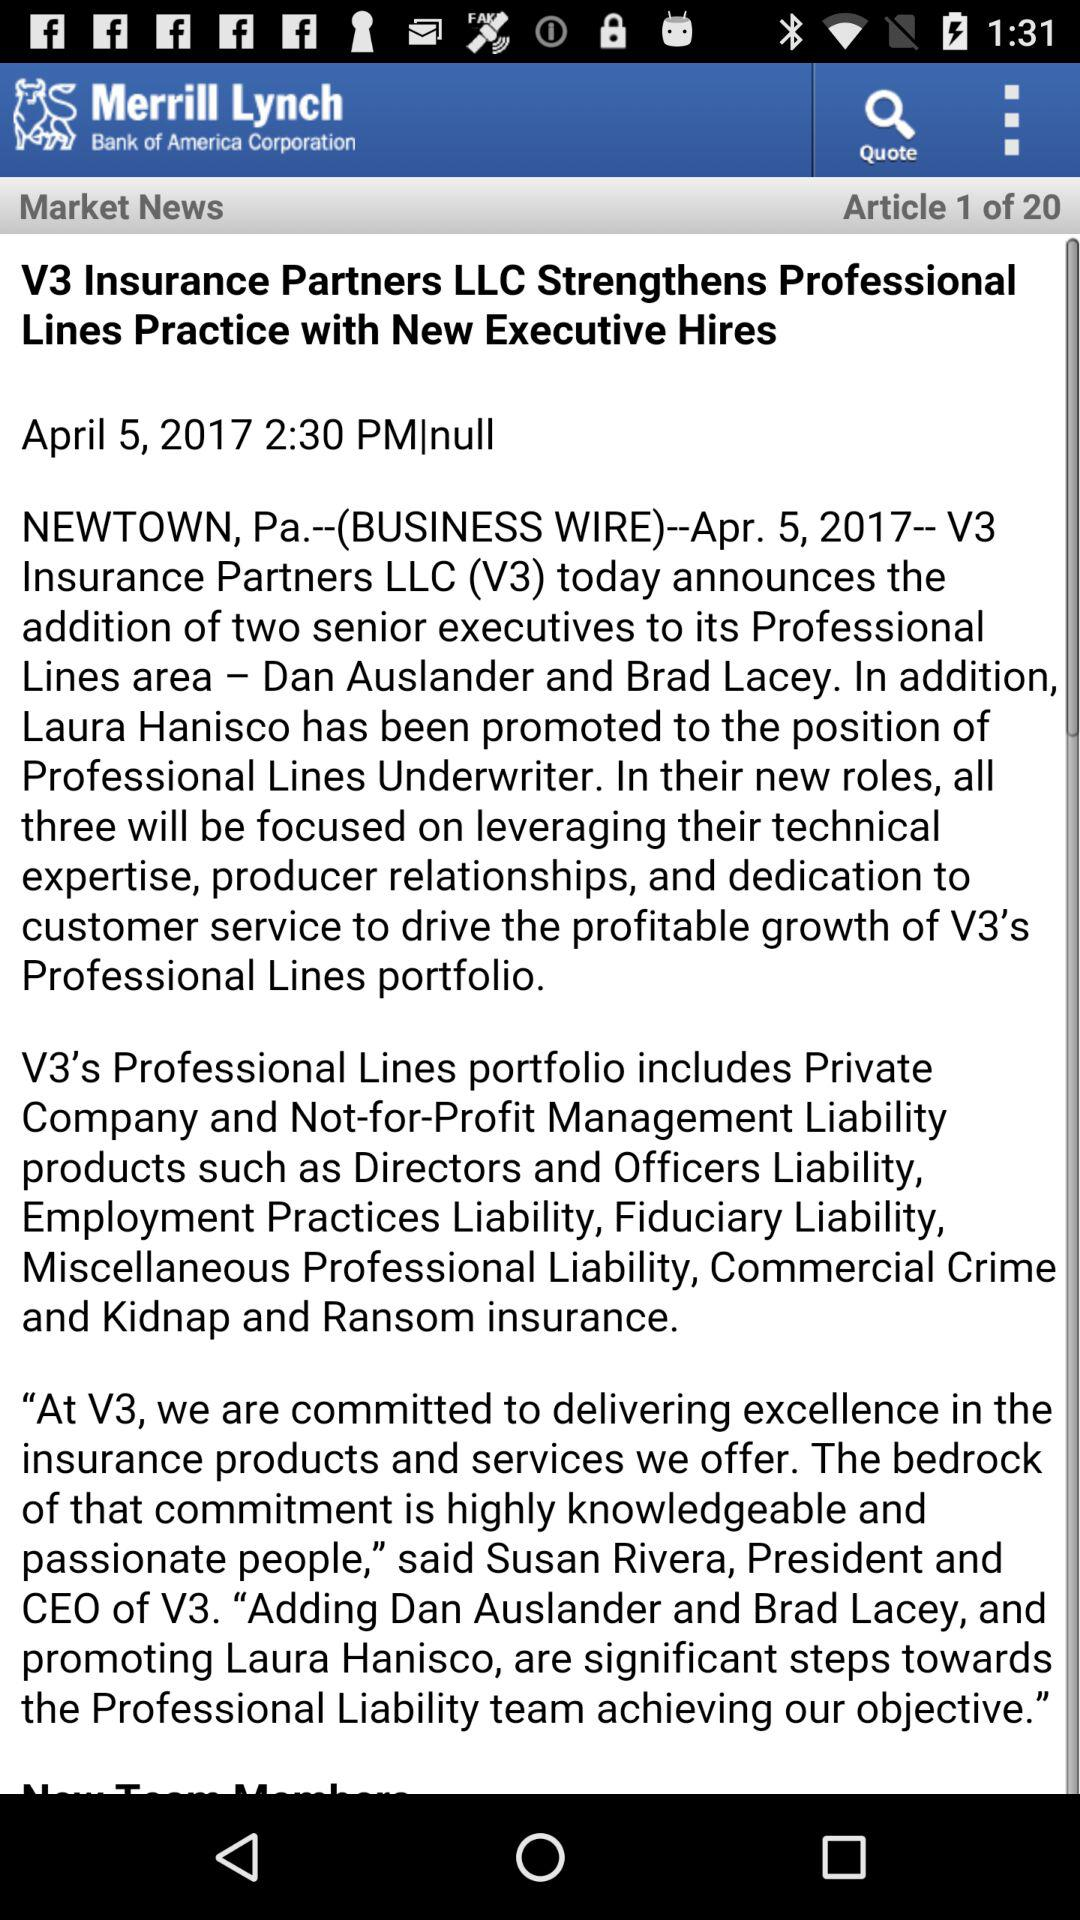What is the title of the article? The title is "V3 Insurance Partners LLC Strengthens Professional Lines Practice with New Executive Hires". 